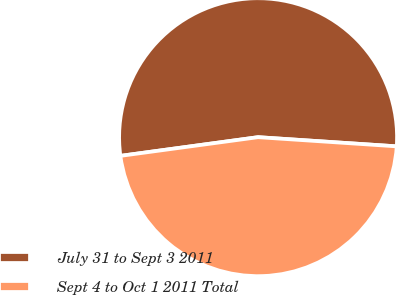Convert chart. <chart><loc_0><loc_0><loc_500><loc_500><pie_chart><fcel>July 31 to Sept 3 2011<fcel>Sept 4 to Oct 1 2011 Total<nl><fcel>53.2%<fcel>46.8%<nl></chart> 